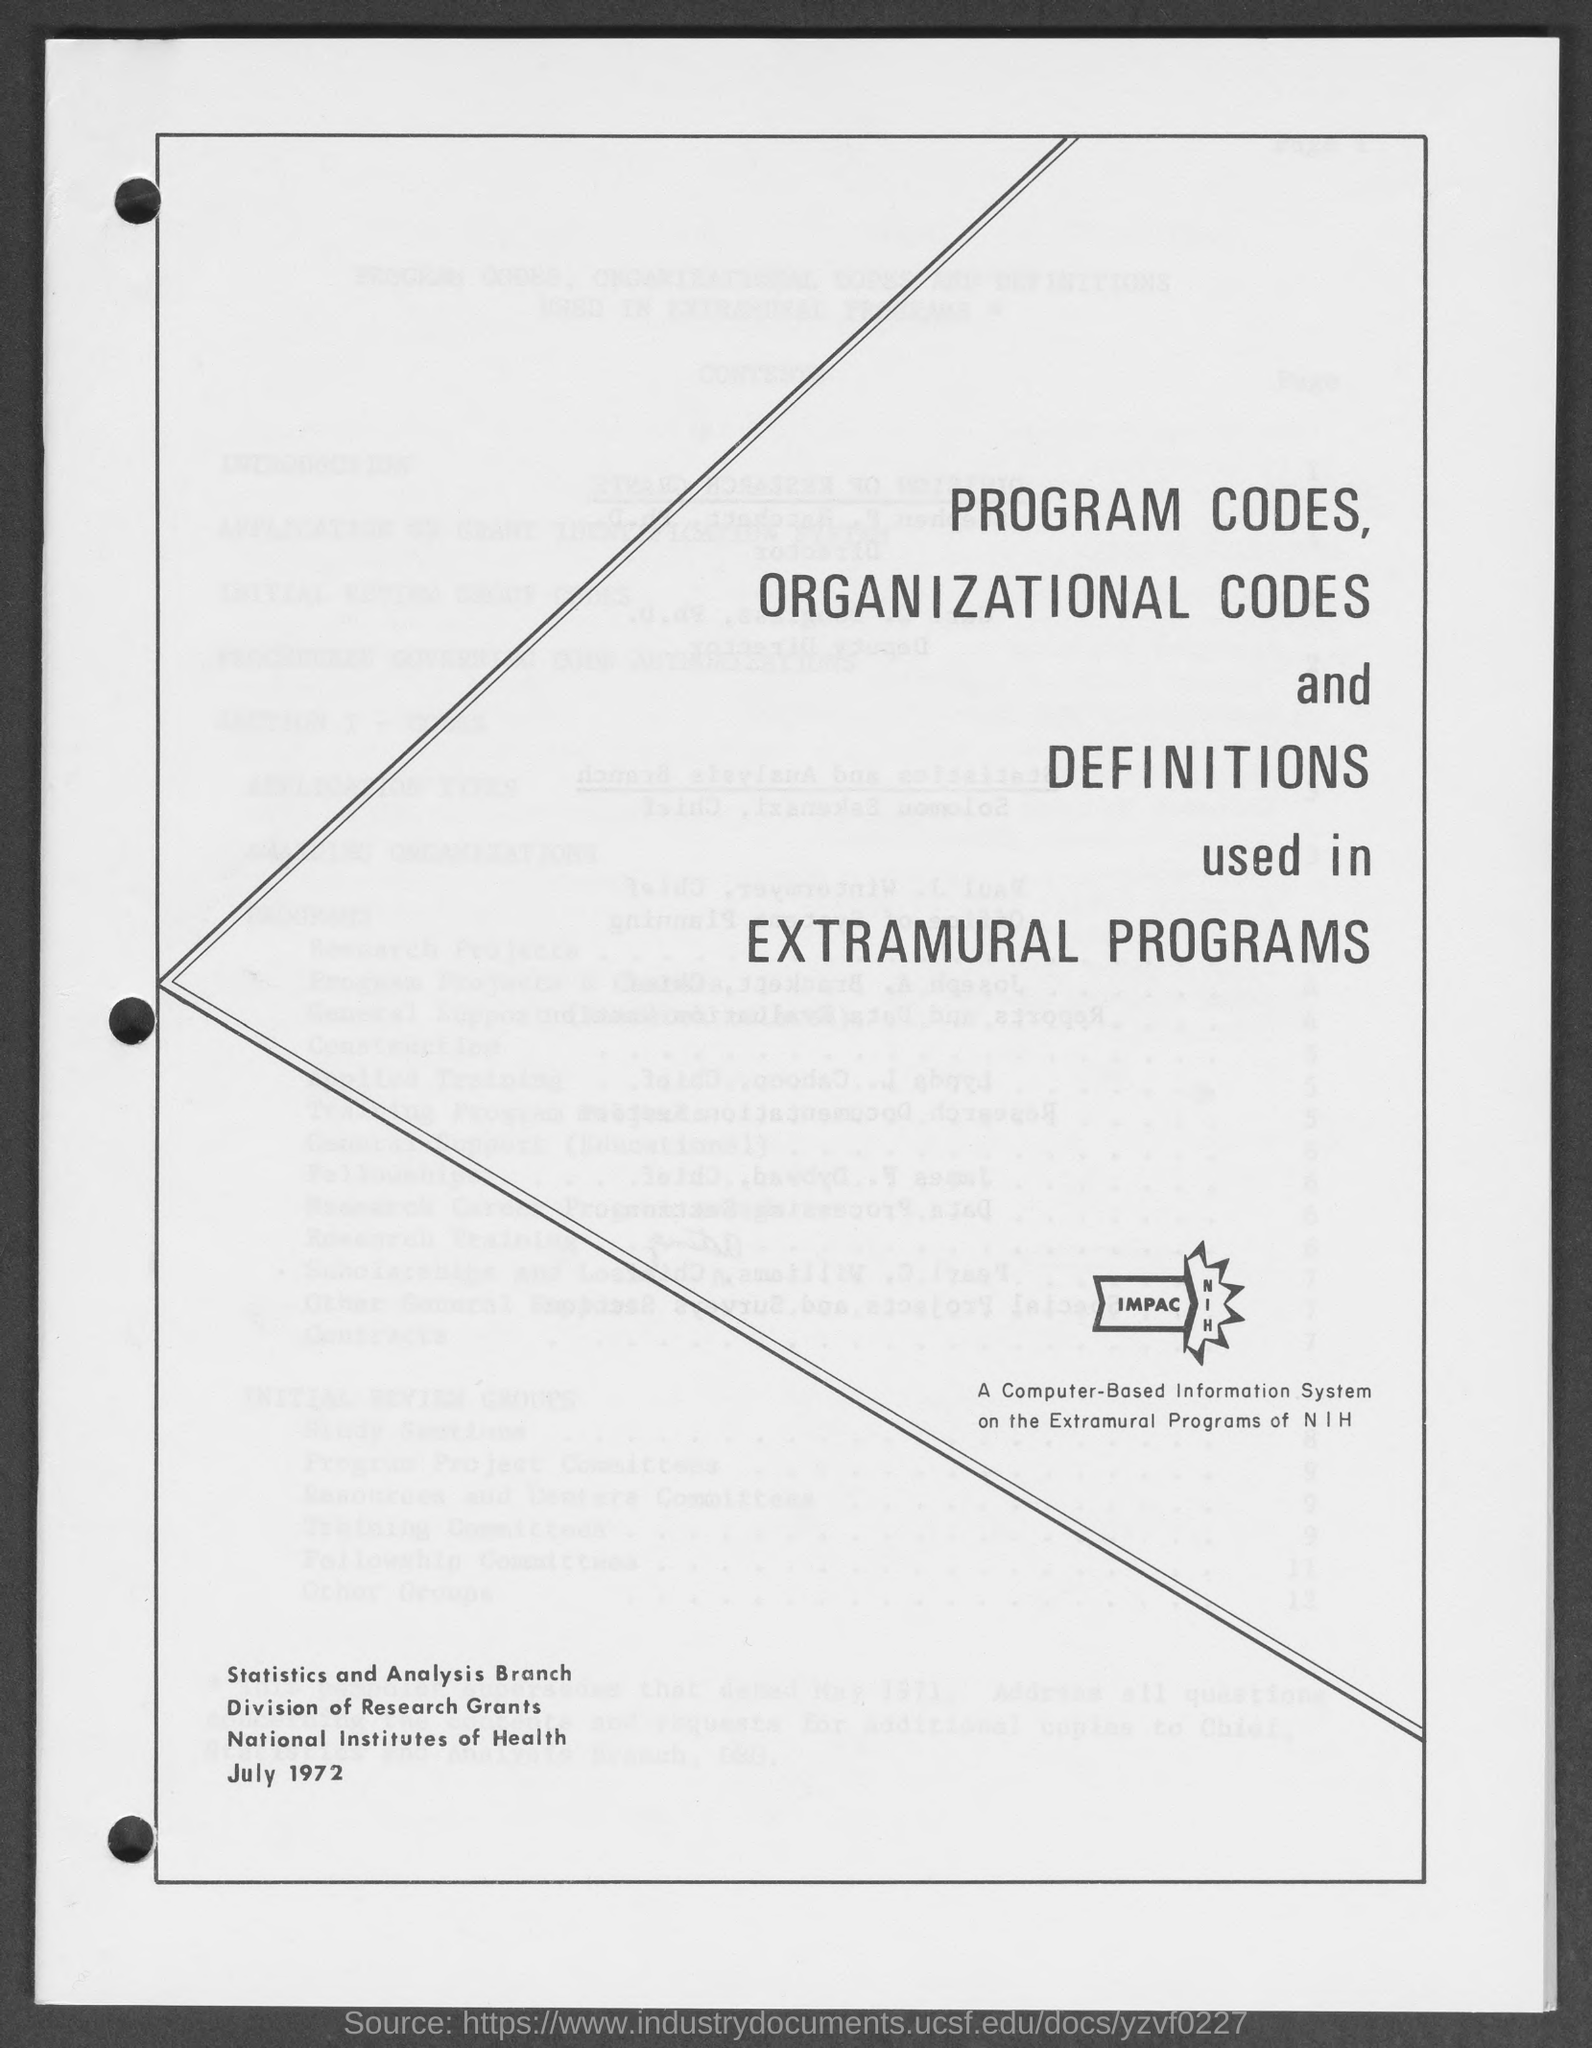What is the month and year at bottom of the page ?
Offer a terse response. July 1972. 